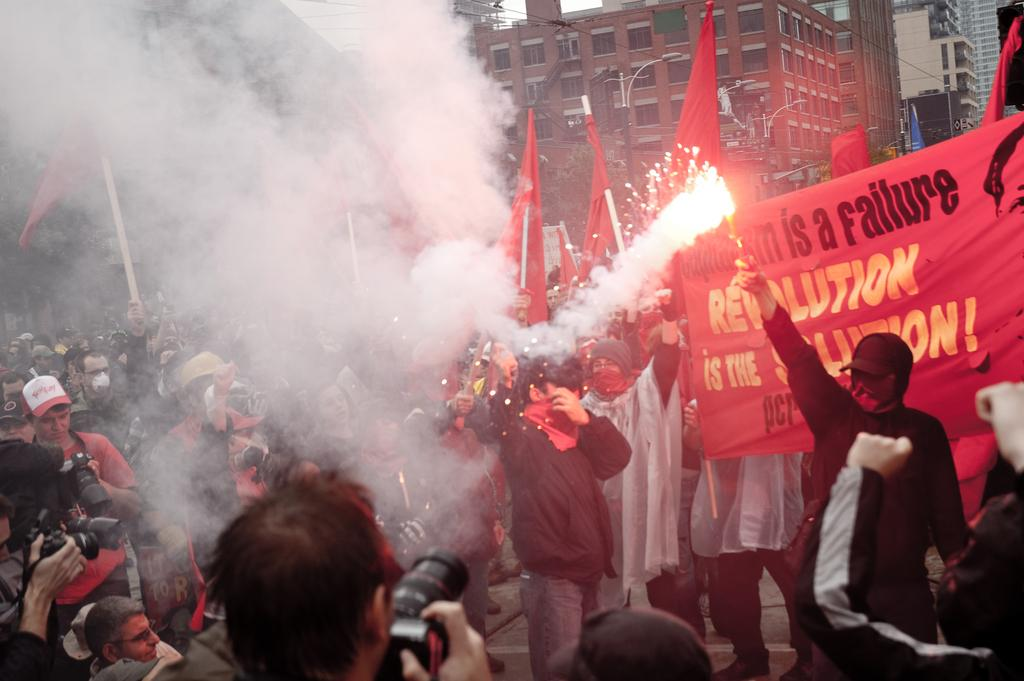Provide a one-sentence caption for the provided image. Protesters light fireworks in support of the Revolution is the Solution movement. 